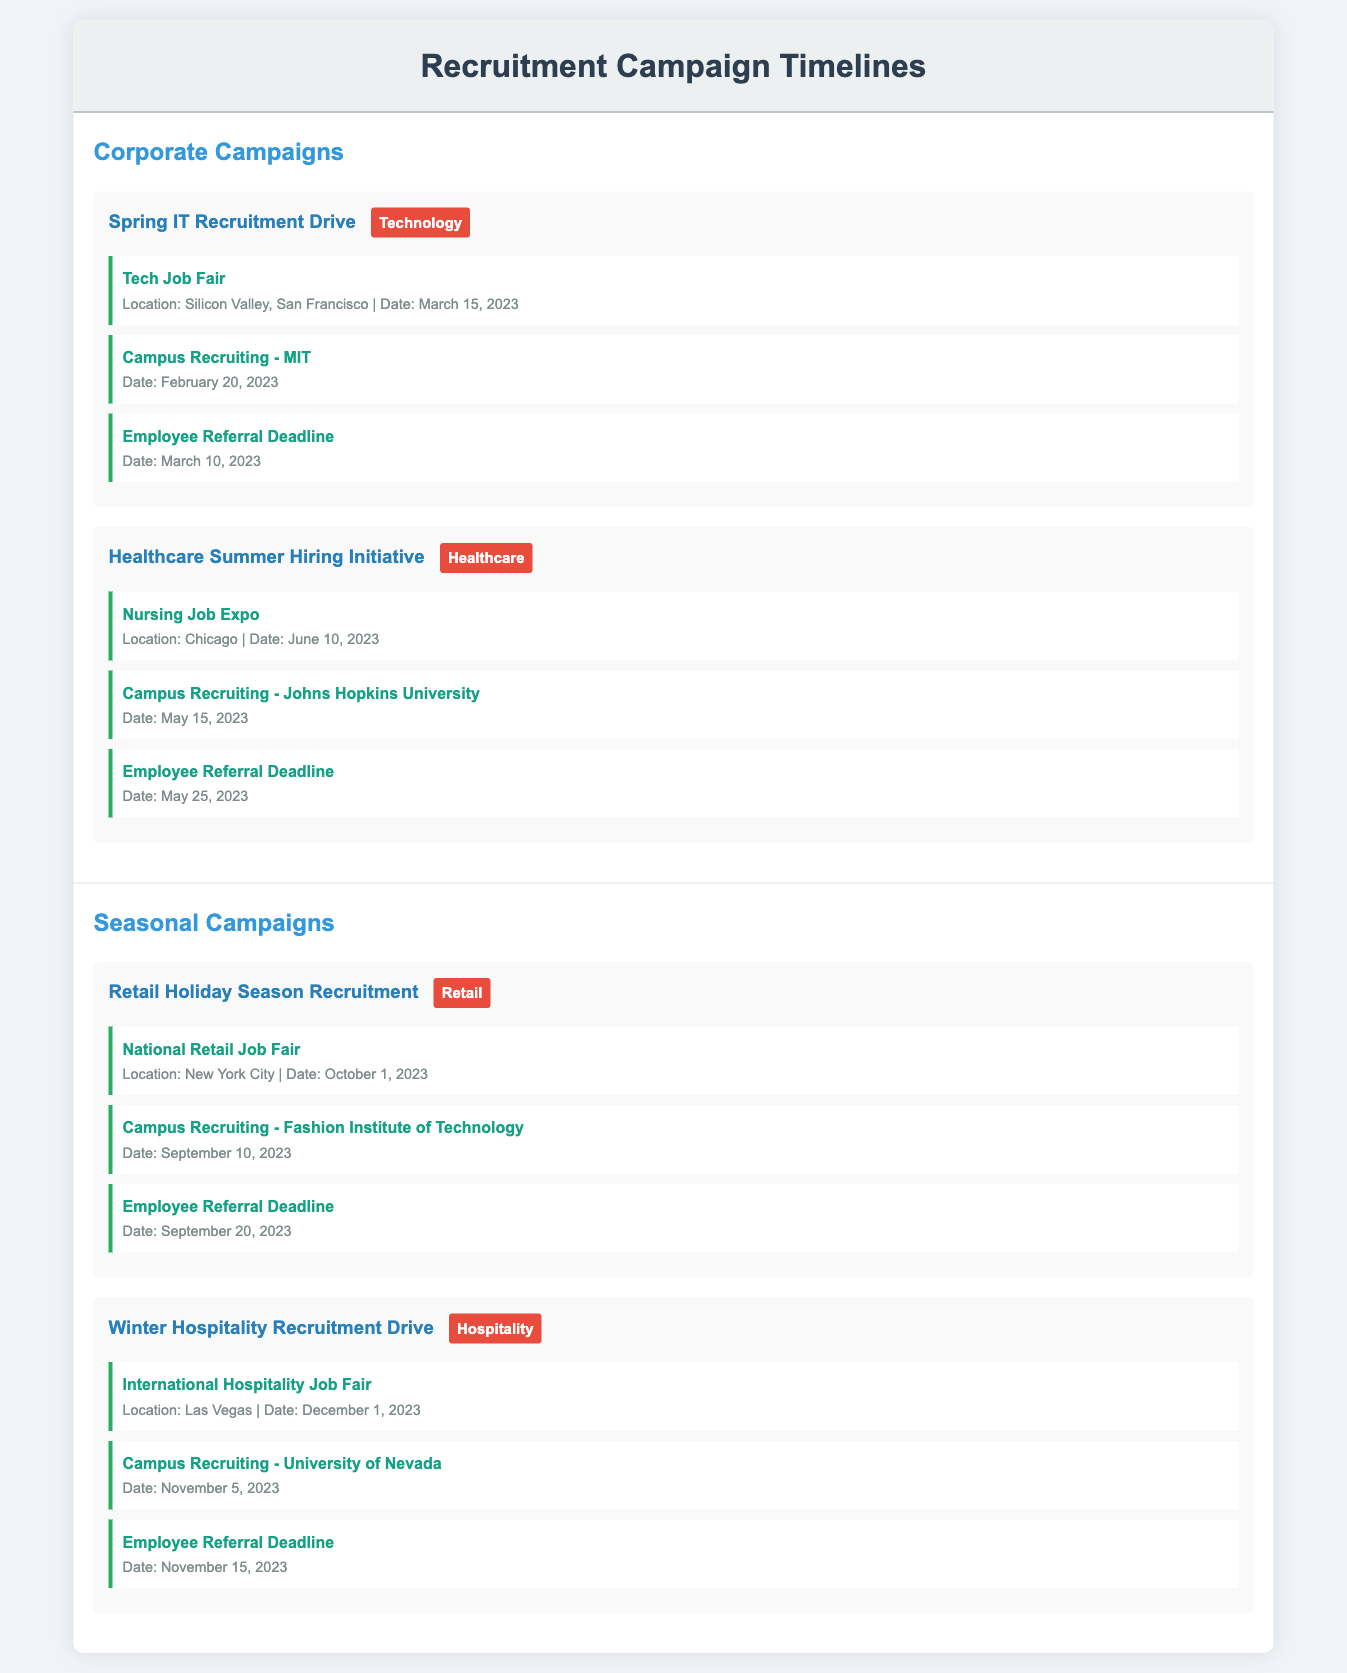what is the date of the Tech Job Fair? The Tech Job Fair is detailed under the Spring IT Recruitment Drive and occurs on March 15, 2023.
Answer: March 15, 2023 which university is participating in campus recruiting on May 15, 2023? The campus recruiting on May 15, 2023 is associated with Johns Hopkins University as mentioned under the Healthcare Summer Hiring Initiative.
Answer: Johns Hopkins University when is the Employee Referral Deadline during the Winter Hospitality Recruitment Drive? The Employee Referral Deadline for the Winter Hospitality Recruitment Drive is noted as November 15, 2023.
Answer: November 15, 2023 what is the location of the National Retail Job Fair? The National Retail Job Fair is scheduled to take place in New York City.
Answer: New York City how many events are listed under the Corporate Campaigns section? The Corporate Campaigns section contains two recruitment campaigns, each with three events, totaling six events.
Answer: 6 events what is the type of industry for the Spring IT Recruitment Drive? The Spring IT Recruitment Drive is categorized under the Technology industry as indicated in the document.
Answer: Technology which month does the Healthcare Summer Hiring Initiative start? The Healthcare Summer Hiring Initiative is set to begin in June, specifically with the Nursing Job Expo on June 10, 2023.
Answer: June what is the date of the campus recruiting event at the Fashion Institute of Technology? The campus recruiting event at the Fashion Institute of Technology is scheduled for September 10, 2023.
Answer: September 10, 2023 